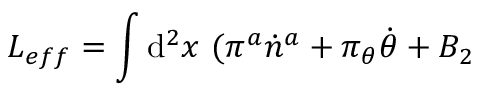Convert formula to latex. <formula><loc_0><loc_0><loc_500><loc_500>L _ { e f f } = \int d ^ { 2 } x ( \pi ^ { a } \dot { n } ^ { a } + \pi _ { \theta } \dot { \theta } + B _ { 2 }</formula> 